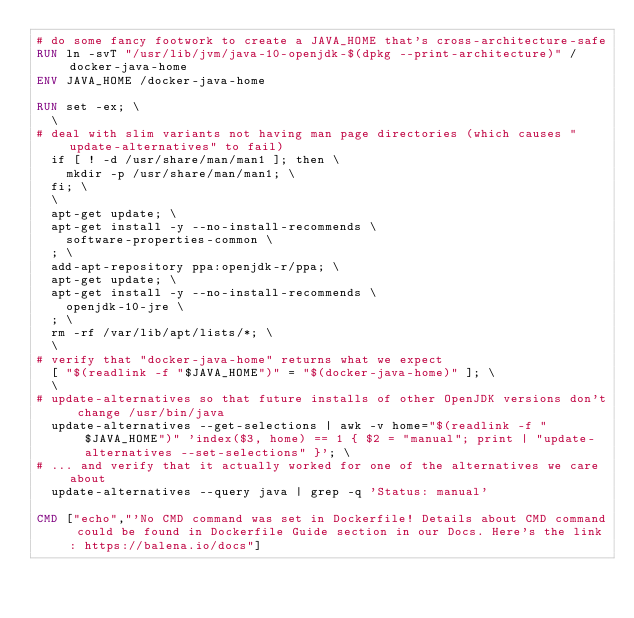Convert code to text. <code><loc_0><loc_0><loc_500><loc_500><_Dockerfile_># do some fancy footwork to create a JAVA_HOME that's cross-architecture-safe
RUN ln -svT "/usr/lib/jvm/java-10-openjdk-$(dpkg --print-architecture)" /docker-java-home
ENV JAVA_HOME /docker-java-home

RUN set -ex; \
	\
# deal with slim variants not having man page directories (which causes "update-alternatives" to fail)
	if [ ! -d /usr/share/man/man1 ]; then \
		mkdir -p /usr/share/man/man1; \
	fi; \
	\
	apt-get update; \
	apt-get install -y --no-install-recommends \
		software-properties-common \
	; \
	add-apt-repository ppa:openjdk-r/ppa; \
	apt-get update; \
	apt-get install -y --no-install-recommends \
		openjdk-10-jre \
	; \
	rm -rf /var/lib/apt/lists/*; \
	\
# verify that "docker-java-home" returns what we expect
	[ "$(readlink -f "$JAVA_HOME")" = "$(docker-java-home)" ]; \
	\
# update-alternatives so that future installs of other OpenJDK versions don't change /usr/bin/java
	update-alternatives --get-selections | awk -v home="$(readlink -f "$JAVA_HOME")" 'index($3, home) == 1 { $2 = "manual"; print | "update-alternatives --set-selections" }'; \
# ... and verify that it actually worked for one of the alternatives we care about
	update-alternatives --query java | grep -q 'Status: manual'

CMD ["echo","'No CMD command was set in Dockerfile! Details about CMD command could be found in Dockerfile Guide section in our Docs. Here's the link: https://balena.io/docs"]</code> 